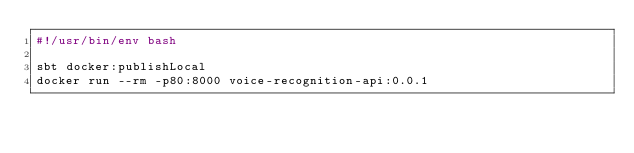Convert code to text. <code><loc_0><loc_0><loc_500><loc_500><_Bash_>#!/usr/bin/env bash

sbt docker:publishLocal
docker run --rm -p80:8000 voice-recognition-api:0.0.1
</code> 